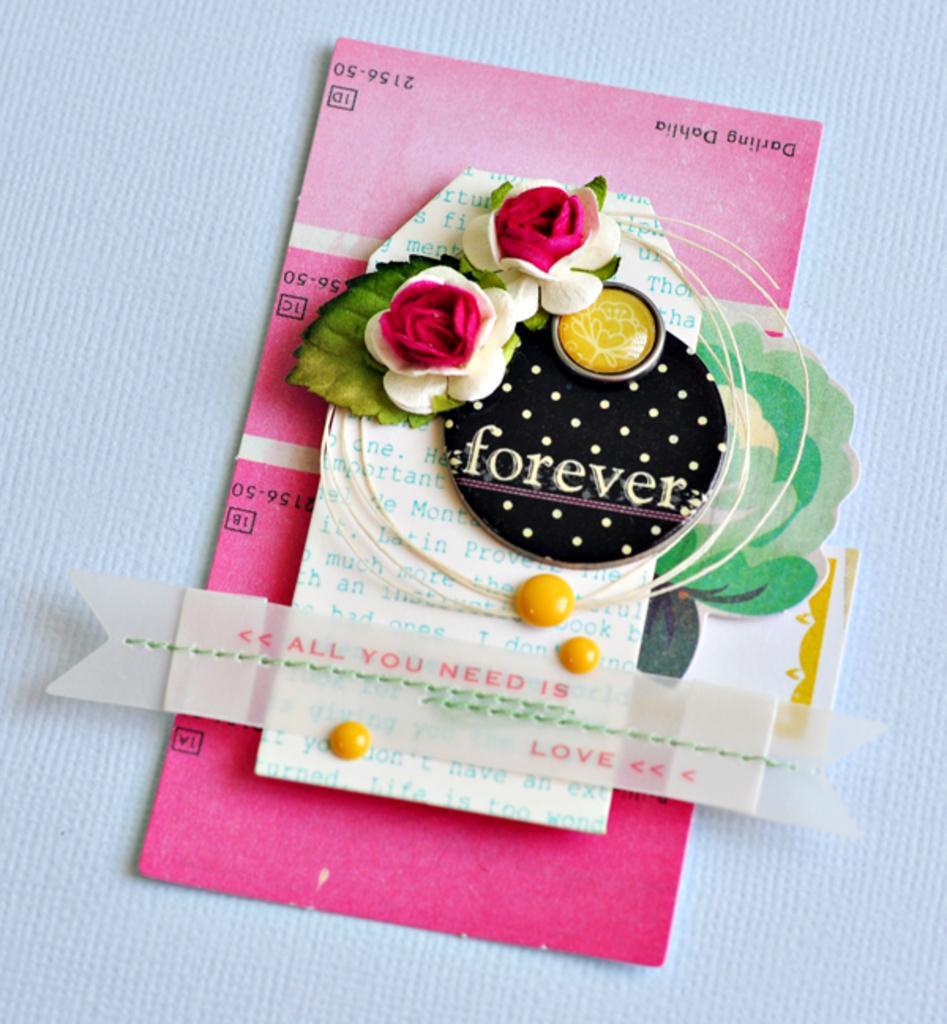Could you give a brief overview of what you see in this image? In this picture I can see greeting card and I can see text and white color background. 